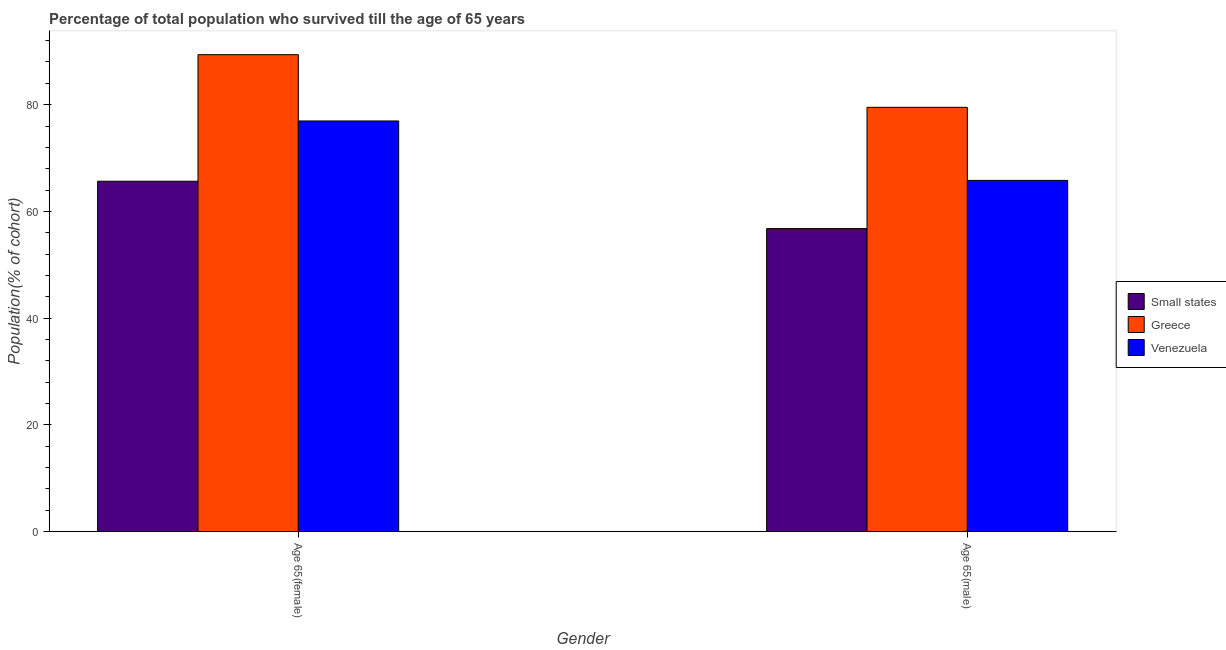How many different coloured bars are there?
Make the answer very short. 3. Are the number of bars per tick equal to the number of legend labels?
Offer a very short reply. Yes. How many bars are there on the 2nd tick from the right?
Give a very brief answer. 3. What is the label of the 2nd group of bars from the left?
Your answer should be very brief. Age 65(male). What is the percentage of male population who survived till age of 65 in Greece?
Your answer should be compact. 79.5. Across all countries, what is the maximum percentage of female population who survived till age of 65?
Offer a terse response. 89.36. Across all countries, what is the minimum percentage of female population who survived till age of 65?
Your response must be concise. 65.65. In which country was the percentage of female population who survived till age of 65 maximum?
Your answer should be very brief. Greece. In which country was the percentage of male population who survived till age of 65 minimum?
Offer a very short reply. Small states. What is the total percentage of female population who survived till age of 65 in the graph?
Provide a short and direct response. 231.96. What is the difference between the percentage of male population who survived till age of 65 in Greece and that in Small states?
Ensure brevity in your answer.  22.71. What is the difference between the percentage of male population who survived till age of 65 in Venezuela and the percentage of female population who survived till age of 65 in Greece?
Your answer should be very brief. -23.55. What is the average percentage of male population who survived till age of 65 per country?
Your answer should be compact. 67.37. What is the difference between the percentage of male population who survived till age of 65 and percentage of female population who survived till age of 65 in Greece?
Provide a succinct answer. -9.86. What is the ratio of the percentage of male population who survived till age of 65 in Greece to that in Venezuela?
Ensure brevity in your answer.  1.21. What does the 3rd bar from the left in Age 65(male) represents?
Provide a short and direct response. Venezuela. What does the 3rd bar from the right in Age 65(male) represents?
Provide a succinct answer. Small states. How many bars are there?
Provide a succinct answer. 6. Are all the bars in the graph horizontal?
Offer a very short reply. No. What is the difference between two consecutive major ticks on the Y-axis?
Keep it short and to the point. 20. Are the values on the major ticks of Y-axis written in scientific E-notation?
Your answer should be very brief. No. What is the title of the graph?
Provide a succinct answer. Percentage of total population who survived till the age of 65 years. Does "Middle East & North Africa (all income levels)" appear as one of the legend labels in the graph?
Make the answer very short. No. What is the label or title of the X-axis?
Provide a succinct answer. Gender. What is the label or title of the Y-axis?
Provide a short and direct response. Population(% of cohort). What is the Population(% of cohort) in Small states in Age 65(female)?
Give a very brief answer. 65.65. What is the Population(% of cohort) in Greece in Age 65(female)?
Keep it short and to the point. 89.36. What is the Population(% of cohort) in Venezuela in Age 65(female)?
Your answer should be compact. 76.94. What is the Population(% of cohort) in Small states in Age 65(male)?
Your answer should be very brief. 56.79. What is the Population(% of cohort) of Greece in Age 65(male)?
Offer a very short reply. 79.5. What is the Population(% of cohort) of Venezuela in Age 65(male)?
Offer a very short reply. 65.81. Across all Gender, what is the maximum Population(% of cohort) of Small states?
Your response must be concise. 65.65. Across all Gender, what is the maximum Population(% of cohort) of Greece?
Give a very brief answer. 89.36. Across all Gender, what is the maximum Population(% of cohort) in Venezuela?
Offer a very short reply. 76.94. Across all Gender, what is the minimum Population(% of cohort) of Small states?
Provide a short and direct response. 56.79. Across all Gender, what is the minimum Population(% of cohort) in Greece?
Your response must be concise. 79.5. Across all Gender, what is the minimum Population(% of cohort) in Venezuela?
Provide a succinct answer. 65.81. What is the total Population(% of cohort) in Small states in the graph?
Give a very brief answer. 122.44. What is the total Population(% of cohort) in Greece in the graph?
Your answer should be compact. 168.86. What is the total Population(% of cohort) of Venezuela in the graph?
Your answer should be very brief. 142.76. What is the difference between the Population(% of cohort) of Small states in Age 65(female) and that in Age 65(male)?
Your answer should be very brief. 8.87. What is the difference between the Population(% of cohort) of Greece in Age 65(female) and that in Age 65(male)?
Give a very brief answer. 9.86. What is the difference between the Population(% of cohort) of Venezuela in Age 65(female) and that in Age 65(male)?
Offer a very short reply. 11.13. What is the difference between the Population(% of cohort) in Small states in Age 65(female) and the Population(% of cohort) in Greece in Age 65(male)?
Make the answer very short. -13.84. What is the difference between the Population(% of cohort) in Small states in Age 65(female) and the Population(% of cohort) in Venezuela in Age 65(male)?
Give a very brief answer. -0.16. What is the difference between the Population(% of cohort) in Greece in Age 65(female) and the Population(% of cohort) in Venezuela in Age 65(male)?
Offer a terse response. 23.55. What is the average Population(% of cohort) of Small states per Gender?
Offer a very short reply. 61.22. What is the average Population(% of cohort) in Greece per Gender?
Offer a very short reply. 84.43. What is the average Population(% of cohort) in Venezuela per Gender?
Your answer should be compact. 71.38. What is the difference between the Population(% of cohort) of Small states and Population(% of cohort) of Greece in Age 65(female)?
Make the answer very short. -23.71. What is the difference between the Population(% of cohort) in Small states and Population(% of cohort) in Venezuela in Age 65(female)?
Provide a short and direct response. -11.29. What is the difference between the Population(% of cohort) in Greece and Population(% of cohort) in Venezuela in Age 65(female)?
Ensure brevity in your answer.  12.42. What is the difference between the Population(% of cohort) in Small states and Population(% of cohort) in Greece in Age 65(male)?
Your response must be concise. -22.71. What is the difference between the Population(% of cohort) in Small states and Population(% of cohort) in Venezuela in Age 65(male)?
Provide a short and direct response. -9.02. What is the difference between the Population(% of cohort) in Greece and Population(% of cohort) in Venezuela in Age 65(male)?
Give a very brief answer. 13.69. What is the ratio of the Population(% of cohort) of Small states in Age 65(female) to that in Age 65(male)?
Keep it short and to the point. 1.16. What is the ratio of the Population(% of cohort) in Greece in Age 65(female) to that in Age 65(male)?
Your answer should be compact. 1.12. What is the ratio of the Population(% of cohort) of Venezuela in Age 65(female) to that in Age 65(male)?
Give a very brief answer. 1.17. What is the difference between the highest and the second highest Population(% of cohort) of Small states?
Your answer should be compact. 8.87. What is the difference between the highest and the second highest Population(% of cohort) of Greece?
Your answer should be compact. 9.86. What is the difference between the highest and the second highest Population(% of cohort) of Venezuela?
Keep it short and to the point. 11.13. What is the difference between the highest and the lowest Population(% of cohort) of Small states?
Provide a short and direct response. 8.87. What is the difference between the highest and the lowest Population(% of cohort) of Greece?
Your answer should be very brief. 9.86. What is the difference between the highest and the lowest Population(% of cohort) in Venezuela?
Keep it short and to the point. 11.13. 